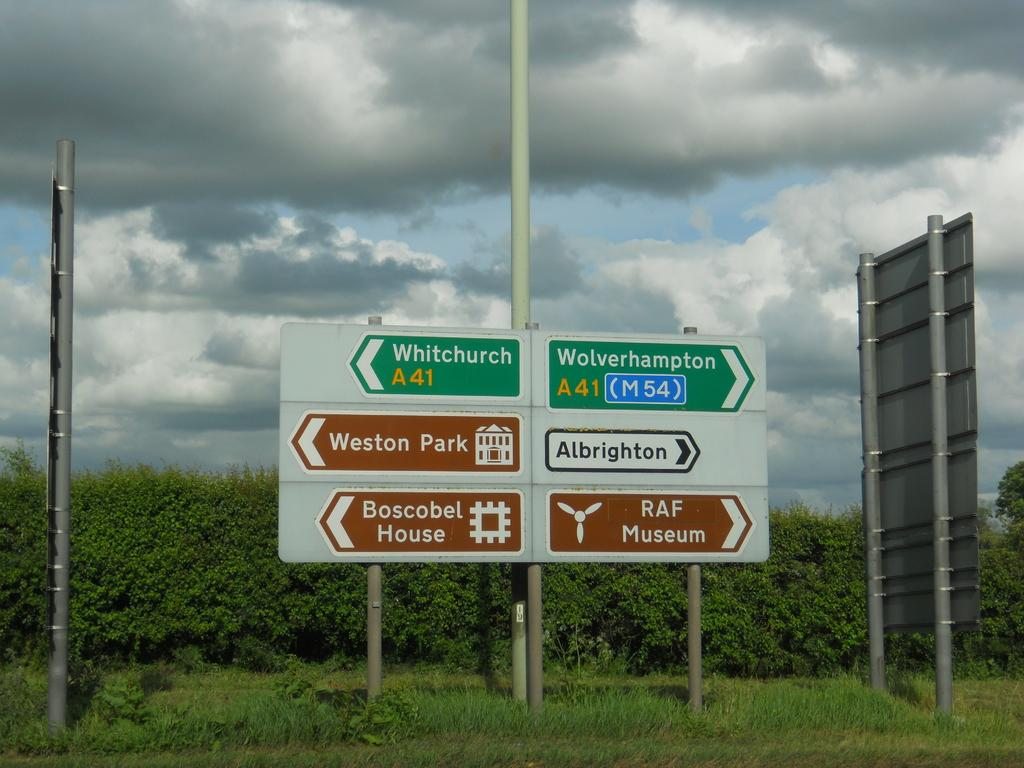<image>
Present a compact description of the photo's key features. A green sign for Whitechurch A 41 points to the west towards Weston Park 